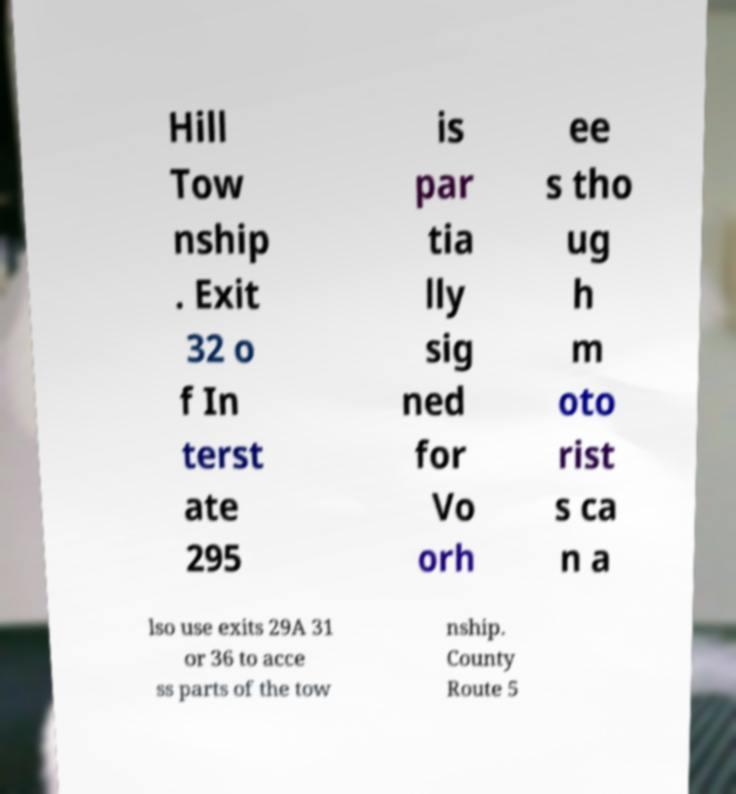Could you extract and type out the text from this image? Hill Tow nship . Exit 32 o f In terst ate 295 is par tia lly sig ned for Vo orh ee s tho ug h m oto rist s ca n a lso use exits 29A 31 or 36 to acce ss parts of the tow nship. County Route 5 